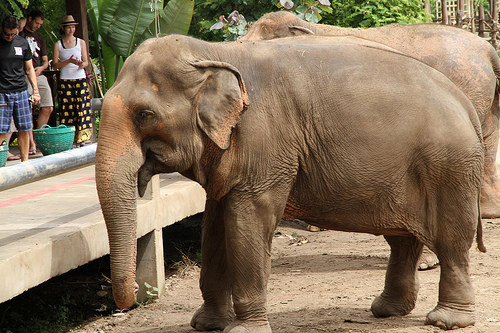What kind is that animal? The animal is an elephant. 